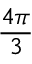Convert formula to latex. <formula><loc_0><loc_0><loc_500><loc_500>\frac { 4 \pi } { 3 }</formula> 